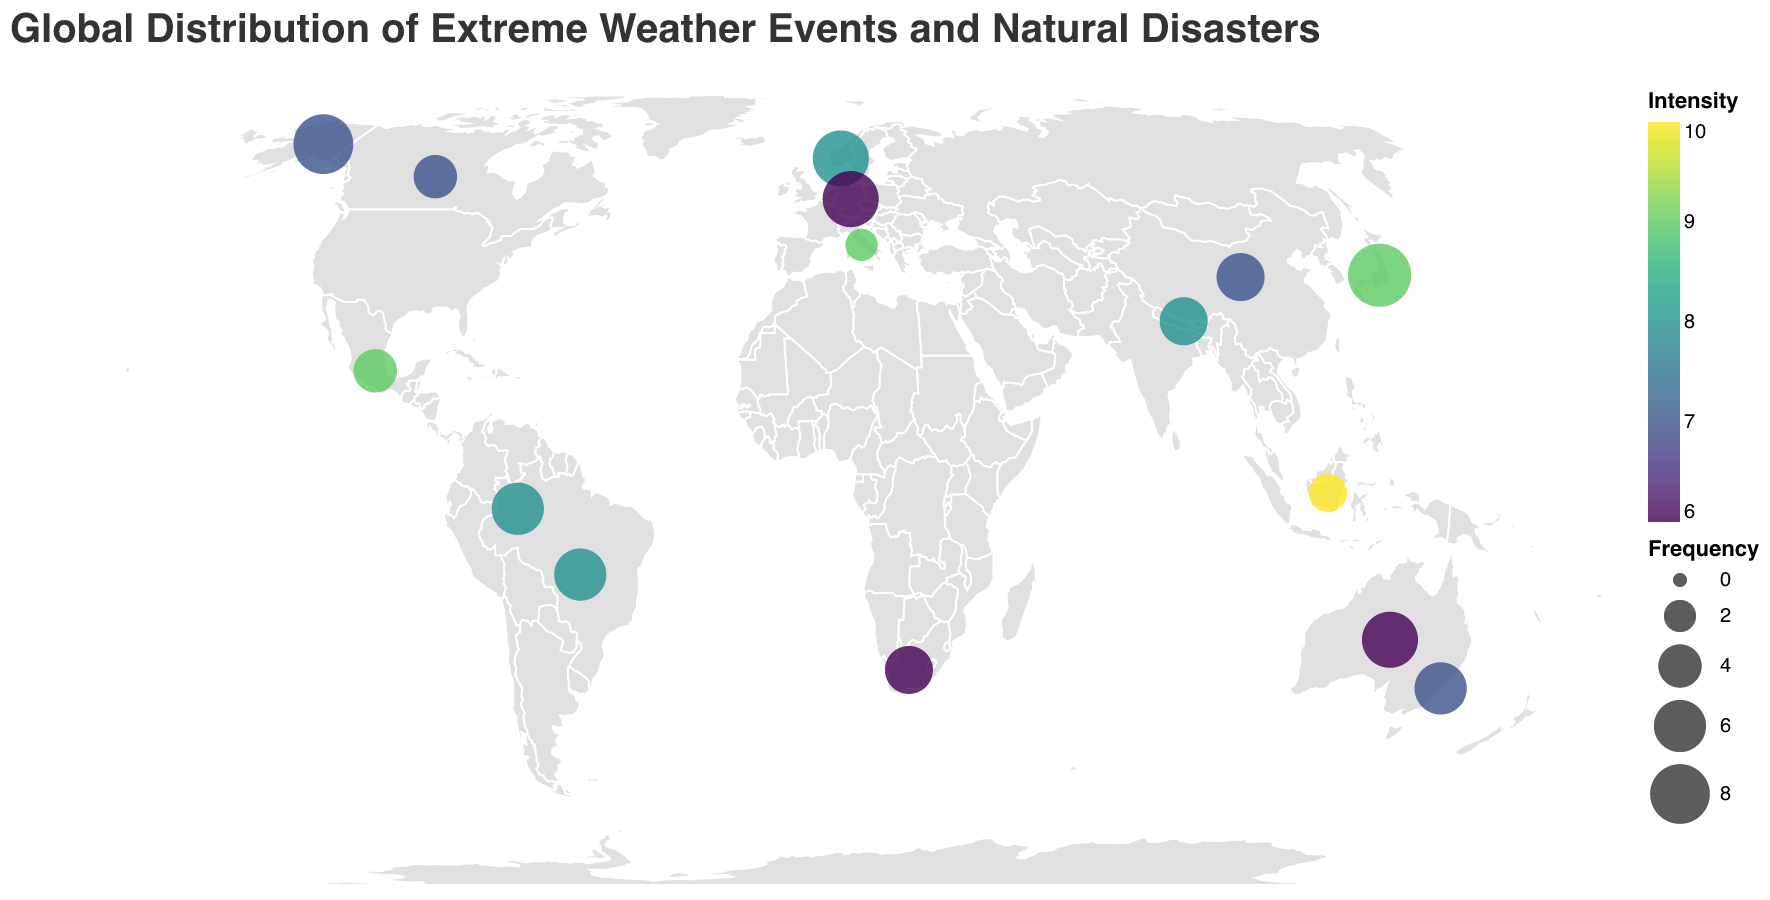What is the most frequent type of extreme weather event on the map? Look for the event with the largest circle size, as circle size represents frequency. The event is Earthquake with a frequency of 9.
Answer: Earthquake Which event has the highest intensity on the map? The color intensity indicates the intensity of the events. The darkest color corresponds to the highest intensity of 10. The event is Tsunami.
Answer: Tsunami How many types of extreme weather events are shown on the map? Count the unique event types mentioned in the tooltip information. There are 15 unique events shown.
Answer: 15 Which extreme weather event has both high survival relevance and occurs frequently? Look for events that have high survival relevance (value close to 9) and large circle size. Avalanche, Wildfire, Blizzard, and Drought fit both criteria, but Wildfire occurs most frequently with a frequency of 8 and survival relevance of 9.
Answer: Wildfire Which event has a higher intensity, Heatwave or Severe Thunderstorm? Compare the color intensity for both events. Heatwaves have an intensity of 7 and Severe Thunderstorms have an intensity of 6.
Answer: Heatwave What is the combined frequency of Flood and Drought events? Flood has a frequency of 6, and Drought has a frequency of 7. The combined frequency is 6 + 7 = 13.
Answer: 13 Which event is the least frequent and where does it occur? Look for the smallest circle size. The event with the smallest circle size (frequency of 2) is the Volcanic Eruption occurring at Latitude 41.9028 and Longitude 12.4964.
Answer: Volcanic Eruption Is a Sandstorm more or less intense than a Tropical Storm? Compare the color intensity of Sandstorm and Tropical Storm. Sandstorm has an intensity of 6 whereas Tropical Storm has an intensity of 8.
Answer: Less Which event has the highest survival relevance, and how frequently does it occur? The highest survival relevance is 9, shared by Wildfire, Drought, Blizzard, and Ice Storm. Among these, Wildfire occurs most frequently with a frequency of 8.
Answer: Wildfire, 8 In which region does the event with the highest intensity occur, and what type of event is it? The event with the highest intensity of 10 is Tsunami, which occurs near Indonesia (Latitude -0.7893 and Longitude 113.9213).
Answer: Indonesia, Tsunami 